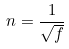<formula> <loc_0><loc_0><loc_500><loc_500>n = \frac { 1 } { \sqrt { f } }</formula> 